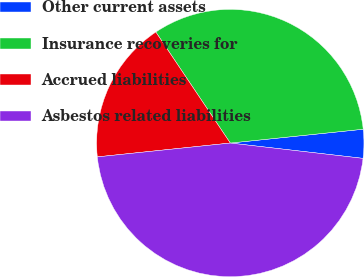Convert chart. <chart><loc_0><loc_0><loc_500><loc_500><pie_chart><fcel>Other current assets<fcel>Insurance recoveries for<fcel>Accrued liabilities<fcel>Asbestos related liabilities<nl><fcel>3.48%<fcel>32.75%<fcel>17.25%<fcel>46.52%<nl></chart> 